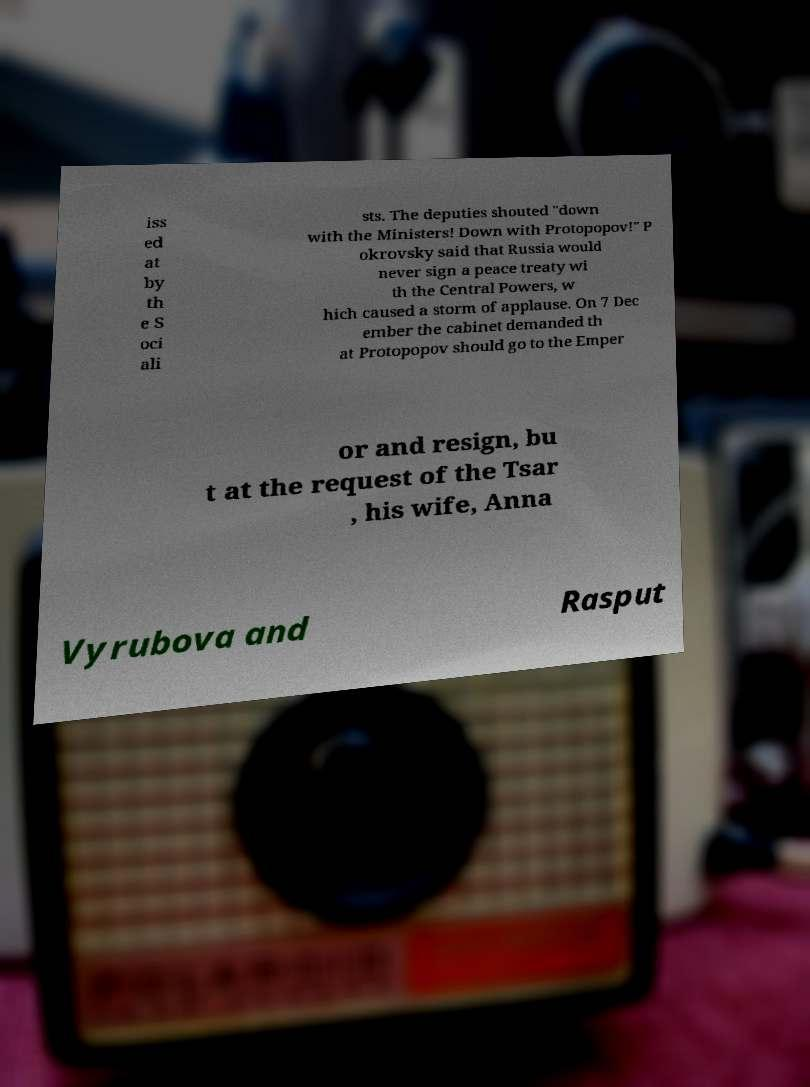Please read and relay the text visible in this image. What does it say? iss ed at by th e S oci ali sts. The deputies shouted "down with the Ministers! Down with Protopopov!" P okrovsky said that Russia would never sign a peace treaty wi th the Central Powers, w hich caused a storm of applause. On 7 Dec ember the cabinet demanded th at Protopopov should go to the Emper or and resign, bu t at the request of the Tsar , his wife, Anna Vyrubova and Rasput 